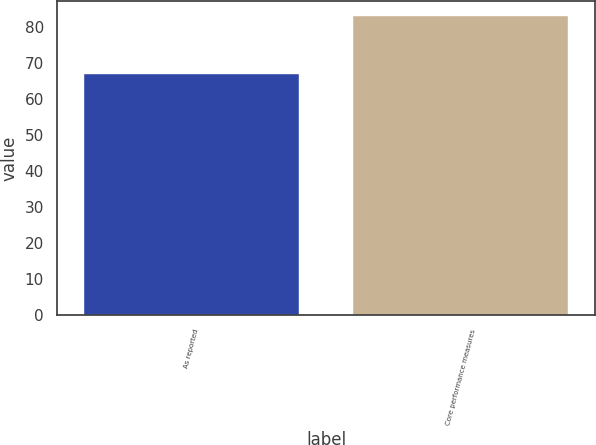Convert chart to OTSL. <chart><loc_0><loc_0><loc_500><loc_500><bar_chart><fcel>As reported<fcel>Core performance measures<nl><fcel>67<fcel>83<nl></chart> 